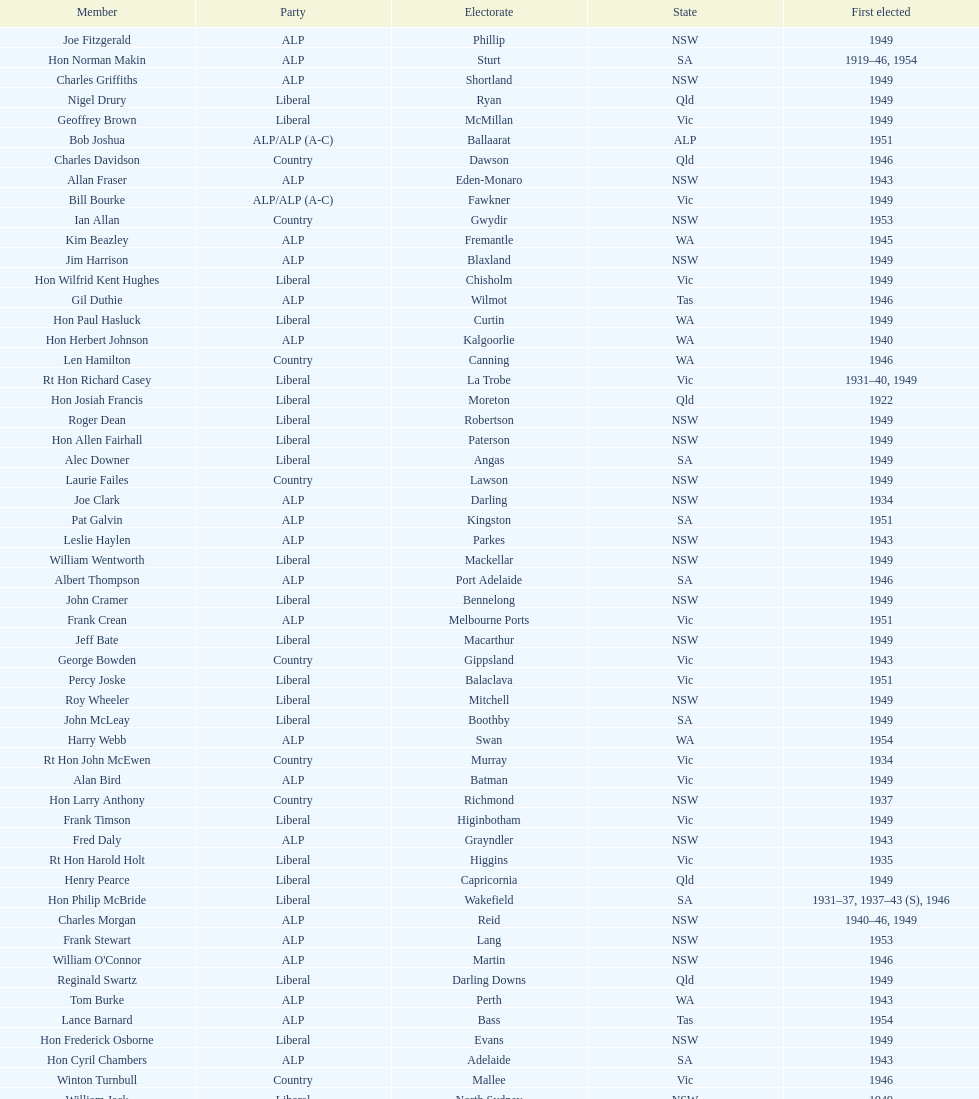After tom burke was elected, what was the next year where another tom would be elected? 1937. Parse the table in full. {'header': ['Member', 'Party', 'Electorate', 'State', 'First elected'], 'rows': [['Joe Fitzgerald', 'ALP', 'Phillip', 'NSW', '1949'], ['Hon Norman Makin', 'ALP', 'Sturt', 'SA', '1919–46, 1954'], ['Charles Griffiths', 'ALP', 'Shortland', 'NSW', '1949'], ['Nigel Drury', 'Liberal', 'Ryan', 'Qld', '1949'], ['Geoffrey Brown', 'Liberal', 'McMillan', 'Vic', '1949'], ['Bob Joshua', 'ALP/ALP (A-C)', 'Ballaarat', 'ALP', '1951'], ['Charles Davidson', 'Country', 'Dawson', 'Qld', '1946'], ['Allan Fraser', 'ALP', 'Eden-Monaro', 'NSW', '1943'], ['Bill Bourke', 'ALP/ALP (A-C)', 'Fawkner', 'Vic', '1949'], ['Ian Allan', 'Country', 'Gwydir', 'NSW', '1953'], ['Kim Beazley', 'ALP', 'Fremantle', 'WA', '1945'], ['Jim Harrison', 'ALP', 'Blaxland', 'NSW', '1949'], ['Hon Wilfrid Kent Hughes', 'Liberal', 'Chisholm', 'Vic', '1949'], ['Gil Duthie', 'ALP', 'Wilmot', 'Tas', '1946'], ['Hon Paul Hasluck', 'Liberal', 'Curtin', 'WA', '1949'], ['Hon Herbert Johnson', 'ALP', 'Kalgoorlie', 'WA', '1940'], ['Len Hamilton', 'Country', 'Canning', 'WA', '1946'], ['Rt Hon Richard Casey', 'Liberal', 'La Trobe', 'Vic', '1931–40, 1949'], ['Hon Josiah Francis', 'Liberal', 'Moreton', 'Qld', '1922'], ['Roger Dean', 'Liberal', 'Robertson', 'NSW', '1949'], ['Hon Allen Fairhall', 'Liberal', 'Paterson', 'NSW', '1949'], ['Alec Downer', 'Liberal', 'Angas', 'SA', '1949'], ['Laurie Failes', 'Country', 'Lawson', 'NSW', '1949'], ['Joe Clark', 'ALP', 'Darling', 'NSW', '1934'], ['Pat Galvin', 'ALP', 'Kingston', 'SA', '1951'], ['Leslie Haylen', 'ALP', 'Parkes', 'NSW', '1943'], ['William Wentworth', 'Liberal', 'Mackellar', 'NSW', '1949'], ['Albert Thompson', 'ALP', 'Port Adelaide', 'SA', '1946'], ['John Cramer', 'Liberal', 'Bennelong', 'NSW', '1949'], ['Frank Crean', 'ALP', 'Melbourne Ports', 'Vic', '1951'], ['Jeff Bate', 'Liberal', 'Macarthur', 'NSW', '1949'], ['George Bowden', 'Country', 'Gippsland', 'Vic', '1943'], ['Percy Joske', 'Liberal', 'Balaclava', 'Vic', '1951'], ['Roy Wheeler', 'Liberal', 'Mitchell', 'NSW', '1949'], ['John McLeay', 'Liberal', 'Boothby', 'SA', '1949'], ['Harry Webb', 'ALP', 'Swan', 'WA', '1954'], ['Rt Hon John McEwen', 'Country', 'Murray', 'Vic', '1934'], ['Alan Bird', 'ALP', 'Batman', 'Vic', '1949'], ['Hon Larry Anthony', 'Country', 'Richmond', 'NSW', '1937'], ['Frank Timson', 'Liberal', 'Higinbotham', 'Vic', '1949'], ['Fred Daly', 'ALP', 'Grayndler', 'NSW', '1943'], ['Rt Hon Harold Holt', 'Liberal', 'Higgins', 'Vic', '1935'], ['Henry Pearce', 'Liberal', 'Capricornia', 'Qld', '1949'], ['Hon Philip McBride', 'Liberal', 'Wakefield', 'SA', '1931–37, 1937–43 (S), 1946'], ['Charles Morgan', 'ALP', 'Reid', 'NSW', '1940–46, 1949'], ['Frank Stewart', 'ALP', 'Lang', 'NSW', '1953'], ["William O'Connor", 'ALP', 'Martin', 'NSW', '1946'], ['Reginald Swartz', 'Liberal', 'Darling Downs', 'Qld', '1949'], ['Tom Burke', 'ALP', 'Perth', 'WA', '1943'], ['Lance Barnard', 'ALP', 'Bass', 'Tas', '1954'], ['Hon Frederick Osborne', 'Liberal', 'Evans', 'NSW', '1949'], ['Hon Cyril Chambers', 'ALP', 'Adelaide', 'SA', '1943'], ['Winton Turnbull', 'Country', 'Mallee', 'Vic', '1946'], ['William Jack', 'Liberal', 'North Sydney', 'NSW', '1949'], ['Aubrey Luck', 'Liberal', 'Darwin', 'Tas', '1951'], ['Rt Hon Robert Menzies', 'Liberal', 'Kooyong', 'Vic', '1934'], ['William Lawrence', 'Liberal', 'Wimmera', 'Vic', '1949'], ['Rowley James', 'ALP', 'Hunter', 'NSW', '1928'], ['Dominic Costa', 'ALP', 'Banks', 'NSW', '1949'], ['Arthur Fuller', 'Country', 'Hume', 'NSW', '1943–49, 1951'], ['Hon Percy Clarey', 'ALP', 'Bendigo', 'Vic', '1949'], ['Rt Hon Sir Earle Page', 'Country', 'Cowper', 'NSW', '1919'], ['Dan Curtin', 'ALP', 'Watson', 'NSW', '1949'], ['Hon Eddie Ward', 'ALP', 'East Sydney', 'NSW', '1931, 1932'], ['Bill Bryson', 'ALP/ALP (A-C)', 'Wills', 'Vic', '1943–1946, 1949'], ['Dan Minogue', 'ALP', 'West Sydney', 'NSW', '1949'], ['Hon Archie Cameron', 'Liberal', 'Barker', 'SA', '1934'], ['Stan Keon', 'ALP/ALP (A-C)', 'Yarra', 'Vic', '1949'], ['Hon Howard Beale', 'Liberal', 'Parramatta', 'NSW', '1946'], ['Bill Edmonds', 'ALP', 'Herbert', 'Qld', '1946'], ['Tom Sheehan', 'ALP', 'Cook', 'NSW', '1937'], ['Bruce Wight', 'Liberal', 'Lilley', 'Qld', '1949'], ['Jack Mullens', 'ALP/ALP (A-C)', 'Gellibrand', 'Vic', '1949'], ['Wilfred Brimblecombe', 'Country', 'Maranoa', 'Qld', '1951'], ['Edgar Russell', 'ALP', 'Grey', 'SA', '1943'], ['Charles Adermann', 'Country', 'Fisher', 'Qld', '1943'], ['Hon Harry Bruce', 'ALP', 'Leichhardt', 'Qld', '1951'], ['Hon Reg Pollard', 'ALP', 'Lalor', 'Vic', '1937'], ['John Howse', 'Liberal', 'Calare', 'NSW', '1946'], ['Hon Bill Riordan', 'ALP', 'Kennedy', 'Qld', '1936'], ['Hon William Haworth', 'Liberal', 'Isaacs', 'Vic', '1949'], ['Hon Athol Townley', 'Liberal', 'Denison', 'Tas', '1949'], ['Frank Davis', 'Liberal', 'Deakin', 'Vic', '1949'], ['William Bostock', 'Liberal', 'Indi', 'Vic', '1949'], ['Alan Hulme', 'Liberal', 'Petrie', 'Qld', '1949'], ['Rt Hon Dr H.V. Evatt', 'ALP', 'Barton', 'NSW', '1940'], ['David Fairbairn', 'Liberal', 'Farrer', 'NSW', '1949'], ['Dan Mackinnon', 'Liberal', 'Corangamite', 'Vic', '1949–51, 1953'], ['Jim Fraser', 'ALP', 'Australian Capital Territory', 'ACT', '1951'], ['Hubert Opperman', 'Liberal', 'Corio', 'Vic', '1949'], ['Tom Andrews', 'ALP/ALP (A-C)', 'Darebin', 'Vic', '1949'], ['Gough Whitlam', 'ALP', 'Werriwa', 'NSW', '1952'], ['Don McLeod', 'Liberal', 'Wannon', 'ALP', '1940–49, 1951'], ['Philip Lucock', 'Country', 'Lyne', 'NSW', '1953'], ['Arthur Greenup', 'ALP', 'Dalley', 'NSW', '1953'], ['Wilfred Coutts', 'ALP', 'Griffith', 'Qld', '1954'], ['Jo Gullett', 'Liberal', 'Henty', 'Vic', '1946'], ['Gordon Freeth', 'Liberal', 'Forrest', 'WA', '1949'], ['Nelson Lemmon', 'ALP', 'St George', 'NSW', '1943–49, 1954'], ['Clyde Cameron', 'ALP', 'Hindmarsh', 'SA', '1949'], ['Hon Arthur Calwell', 'ALP', 'Melbourne', 'Vic', '1940'], ['Jack Cremean', 'ALP/ALP (A-C)', 'Hoddle', 'Vic', '1949'], ['Ted Peters', 'ALP', 'Burke', 'Vic', '1949'], ['Rt Hon Arthur Fadden', 'Country', 'McPherson', 'Qld', '1949'], ['Hon George Lawson', 'ALP', 'Brisbane', 'Qld', '1931'], ['Harry Turner', 'Liberal', 'Bradfield', 'NSW', '1952'], ['Hon David Drummond', 'Country', 'New England', 'NSW', '1949'], ['William Brand', 'Country', 'Wide Bay', 'Qld', '1954'], ['Robert Lindsay', 'Liberal', 'Flinders', 'Vic', '1954'], ['Malcolm McColm', 'Liberal', 'Bowman', 'Qld', '1949'], ['Bill Falkinder', 'Liberal', 'Franklin', 'Tas', '1946'], ['Hugh Leslie', 'Liberal', 'Moore', 'Country', '1949'], ['Billy Davies', 'ALP', 'Cunningham', 'NSW', '1949'], ['Hon Arthur Drakeford', 'ALP', 'Maribyrnong', 'Vic', '1934'], ['Rt Hon Eric Harrison', 'Liberal', 'Wentworth', 'NSW', '1931'], ['Gordon Anderson', 'ALP', 'Kingsford Smith', 'NSW', '1949'], ['Jock Nelson', 'ALP', 'Northern Territory', 'NT', '1949'], ['Jim Cope', 'ALP', 'Cook', 'NSW', '1955'], ['Dr Donald Cameron', 'Liberal', 'Oxley', 'Qld', '1949'], ['David Oliver Watkins', 'ALP', 'Newcastle', 'NSW', '1935'], ['Francis Bland', 'Liberal', 'Warringah', 'NSW', '1951'], ['Hugh Roberton', 'Country', 'Riverina', 'NSW', '1949'], ['Tony Luchetti', 'ALP', 'Macquarie', 'NSW', '1951'], ['Hon William McMahon', 'Liberal', 'Lowe', 'NSW', '1949']]} 